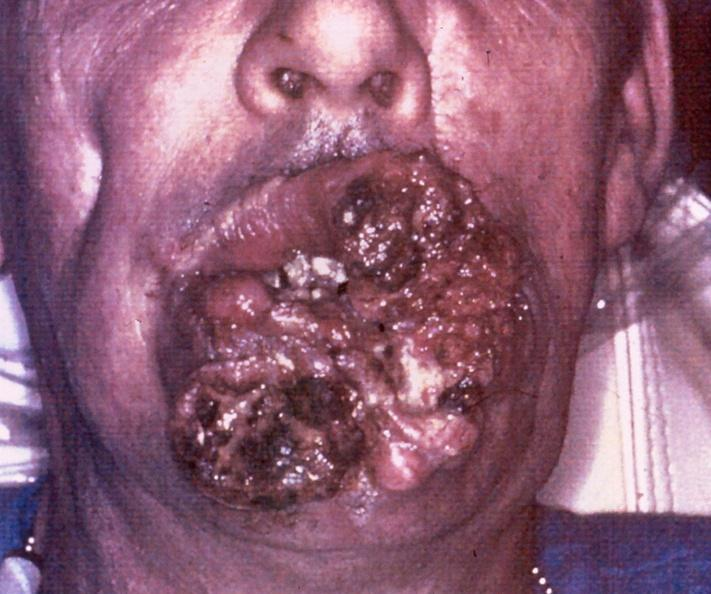s close-up excellent example of interosseous muscle atrophy present?
Answer the question using a single word or phrase. No 